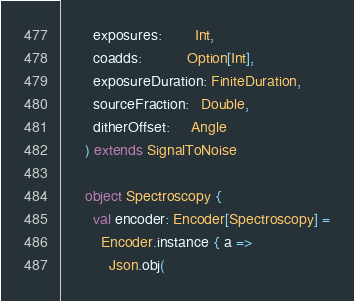<code> <loc_0><loc_0><loc_500><loc_500><_Scala_>        exposures:        Int,
        coadds:           Option[Int],
        exposureDuration: FiniteDuration,
        sourceFraction:   Double,
        ditherOffset:     Angle
      ) extends SignalToNoise

      object Spectroscopy {
        val encoder: Encoder[Spectroscopy] =
          Encoder.instance { a =>
            Json.obj(</code> 